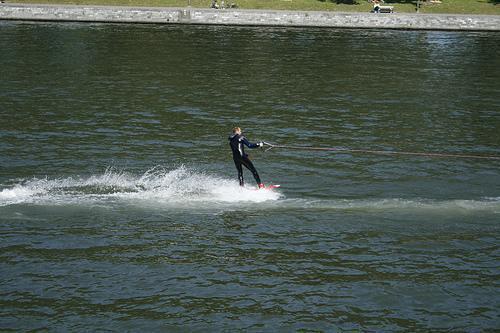How many people in the water?
Give a very brief answer. 1. How many red ropes do you see in the picture?
Give a very brief answer. 1. 